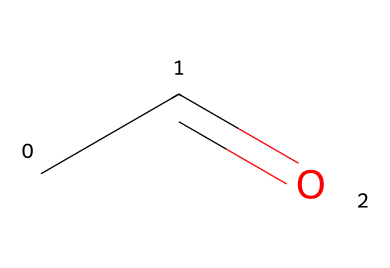What is the name of this chemical? The SMILES representation "CC=O" indicates a two-carbon chain with a carbonyl group (C=O) at the end. This corresponds to the chemical name acetaldehyde.
Answer: acetaldehyde How many carbon atoms are present in the structure? The SMILES "CC=O" shows two 'C' characters, indicating there are two carbon atoms in the structure.
Answer: 2 How many oxygen atoms are in the molecule? The 'O' in "CC=O" indicates there is one oxygen atom present in the structure, which is part of the carbonyl functional group.
Answer: 1 What type of functional group is present in this molecule? The structure features a carbonyl group (C=O) at the end of the carbon chain, typical of aldehydes. Therefore, the functional group is an aldehyde.
Answer: aldehyde What is the molecular formula of this compound? From the SMILES representation, we identify 2 carbon atoms (C), 4 hydrogen atoms (H), and 1 oxygen atom (O). Thus, the molecular formula is C2H4O.
Answer: C2H4O Why is acetaldehyde considered an aldehyde? Acetaldehyde has a carbonyl group (C=O) that is bonded to a hydrogen atom, which qualifies it as an aldehyde. Aldehydes are defined by having a carbonyl group at the end of a carbon chain.
Answer: carbonyl group How does the presence of the carbonyl group affect the reactivity of this molecule? The carbonyl group in aldehydes is polar, making acetaldehyde more reactive compared to alkanes. It can participate in various chemical reactions, such as oxidation and nucleophilic addition.
Answer: more reactive 